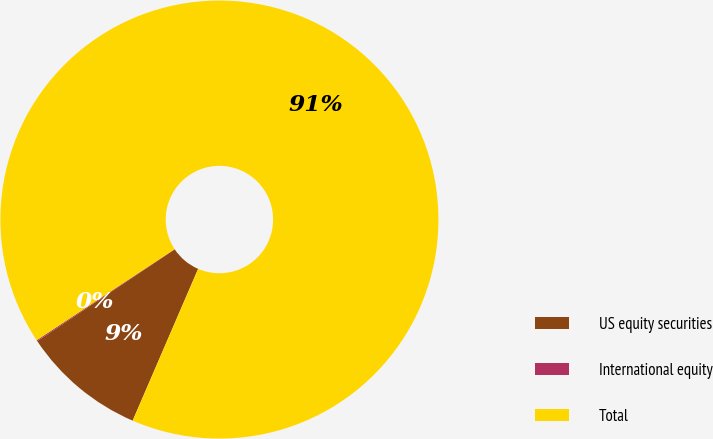Convert chart. <chart><loc_0><loc_0><loc_500><loc_500><pie_chart><fcel>US equity securities<fcel>International equity<fcel>Total<nl><fcel>9.15%<fcel>0.08%<fcel>90.77%<nl></chart> 